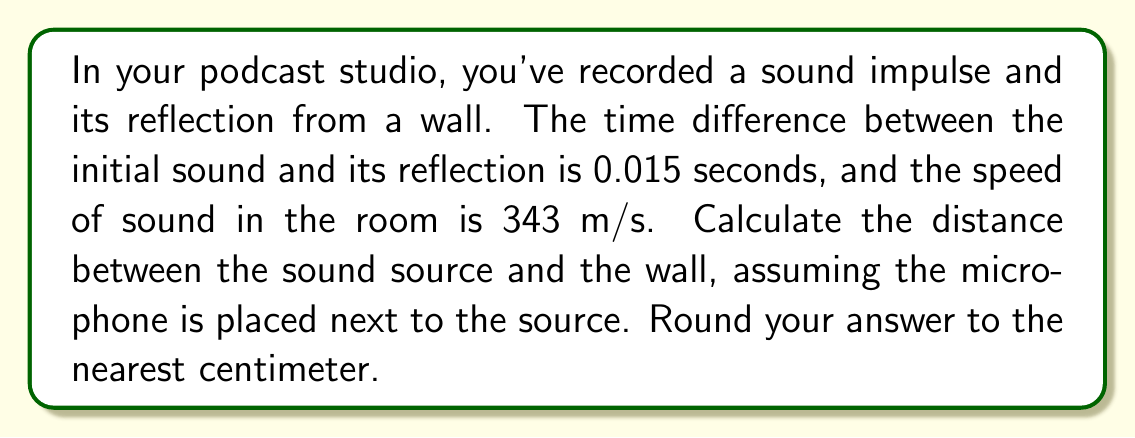Can you answer this question? To solve this problem, we'll use the following steps:

1. Understand the given information:
   - Time difference between initial sound and reflection: $t = 0.015$ seconds
   - Speed of sound: $v = 343$ m/s

2. Calculate the total distance traveled by the sound:
   The sound travels from the source to the wall and back to the microphone.
   Total distance = $d = v \times t$
   $d = 343 \text{ m/s} \times 0.015 \text{ s} = 5.145 \text{ m}$

3. Find the distance to the wall:
   Since the sound travels to the wall and back, the actual distance to the wall is half of the total distance traveled.
   Distance to wall = $\frac{d}{2} = \frac{5.145 \text{ m}}{2} = 2.5725 \text{ m}$

4. Round the result to the nearest centimeter:
   $2.5725 \text{ m} = 257.25 \text{ cm}$
   Rounded to the nearest centimeter: $257 \text{ cm}$

This calculation helps determine the acoustic properties of the room by finding the distance to one of the reflective surfaces, which is crucial for understanding sound behavior in the studio space.
Answer: 257 cm 